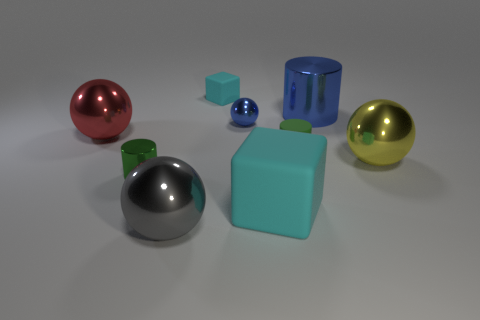There is a tiny green cylinder in front of the large thing to the right of the blue thing that is on the right side of the large cube; what is it made of?
Your answer should be very brief. Metal. How many green rubber cylinders are there?
Your response must be concise. 1. How many cyan objects are small spheres or things?
Offer a terse response. 2. What number of other objects are there of the same shape as the red object?
Keep it short and to the point. 3. Do the matte block on the right side of the small blue shiny thing and the rubber block that is behind the yellow shiny object have the same color?
Ensure brevity in your answer.  Yes. How many large things are red metallic objects or cyan objects?
Your response must be concise. 2. There is a blue object that is the same shape as the green shiny object; what size is it?
Ensure brevity in your answer.  Large. What is the big object behind the large metallic sphere behind the big yellow object made of?
Give a very brief answer. Metal. What number of metal objects are small green cubes or small green cylinders?
Provide a succinct answer. 1. There is a tiny metal object that is the same shape as the big gray shiny object; what color is it?
Provide a succinct answer. Blue. 